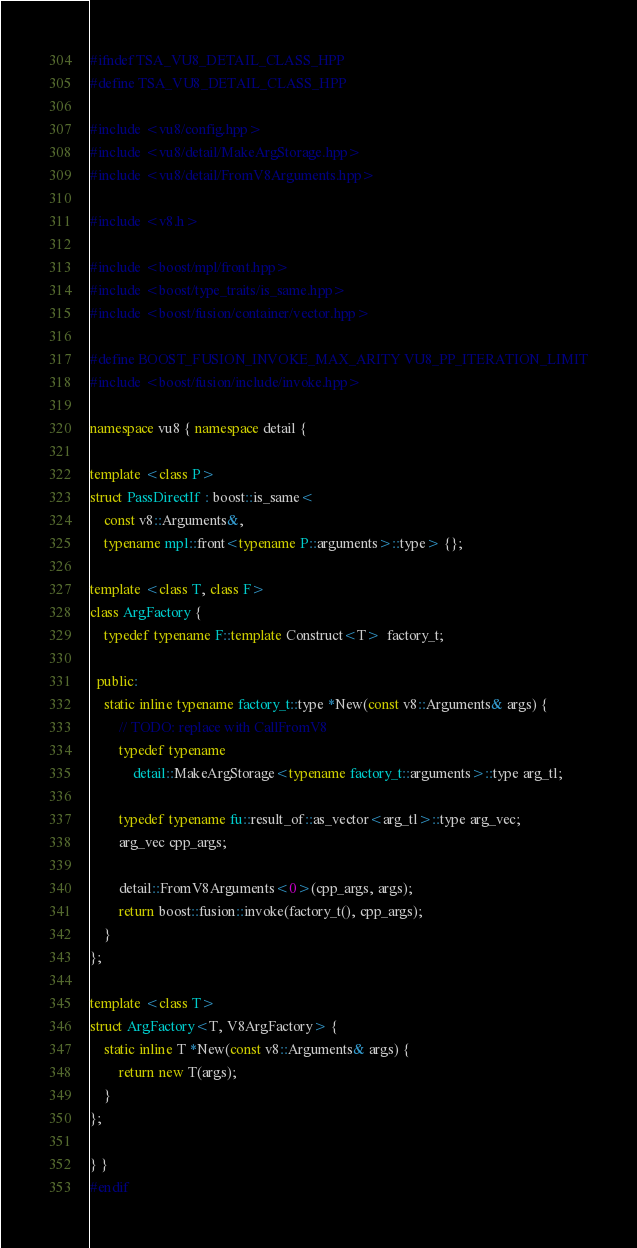Convert code to text. <code><loc_0><loc_0><loc_500><loc_500><_C++_>#ifndef TSA_VU8_DETAIL_CLASS_HPP
#define TSA_VU8_DETAIL_CLASS_HPP

#include <vu8/config.hpp>
#include <vu8/detail/MakeArgStorage.hpp>
#include <vu8/detail/FromV8Arguments.hpp>

#include <v8.h>

#include <boost/mpl/front.hpp>
#include <boost/type_traits/is_same.hpp>
#include <boost/fusion/container/vector.hpp>

#define BOOST_FUSION_INVOKE_MAX_ARITY VU8_PP_ITERATION_LIMIT
#include <boost/fusion/include/invoke.hpp>

namespace vu8 { namespace detail {

template <class P>
struct PassDirectIf : boost::is_same<
    const v8::Arguments&,
    typename mpl::front<typename P::arguments>::type> {};

template <class T, class F>
class ArgFactory {
    typedef typename F::template Construct<T>  factory_t;

  public:
    static inline typename factory_t::type *New(const v8::Arguments& args) {
        // TODO: replace with CallFromV8
        typedef typename
            detail::MakeArgStorage<typename factory_t::arguments>::type arg_tl;

        typedef typename fu::result_of::as_vector<arg_tl>::type arg_vec;
        arg_vec cpp_args;

        detail::FromV8Arguments<0>(cpp_args, args);
        return boost::fusion::invoke(factory_t(), cpp_args);
    }
};

template <class T>
struct ArgFactory<T, V8ArgFactory> {
    static inline T *New(const v8::Arguments& args) {
        return new T(args);
    }
};

} }
#endif
</code> 